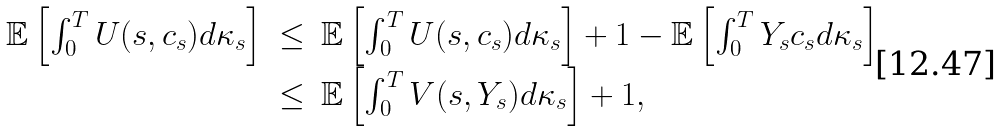Convert formula to latex. <formula><loc_0><loc_0><loc_500><loc_500>\begin{array} { r c l } \mathbb { E } \left [ \int _ { 0 } ^ { T } U ( s , c _ { s } ) d \kappa _ { s } \right ] & \leq & \mathbb { E } \left [ \int _ { 0 } ^ { T } U ( s , c _ { s } ) d \kappa _ { s } \right ] + 1 - \mathbb { E } \left [ \int _ { 0 } ^ { T } Y _ { s } c _ { s } d \kappa _ { s } \right ] \\ & \leq & \mathbb { E } \left [ \int _ { 0 } ^ { T } V ( s , Y _ { s } ) d \kappa _ { s } \right ] + 1 , \\ \end{array}</formula> 